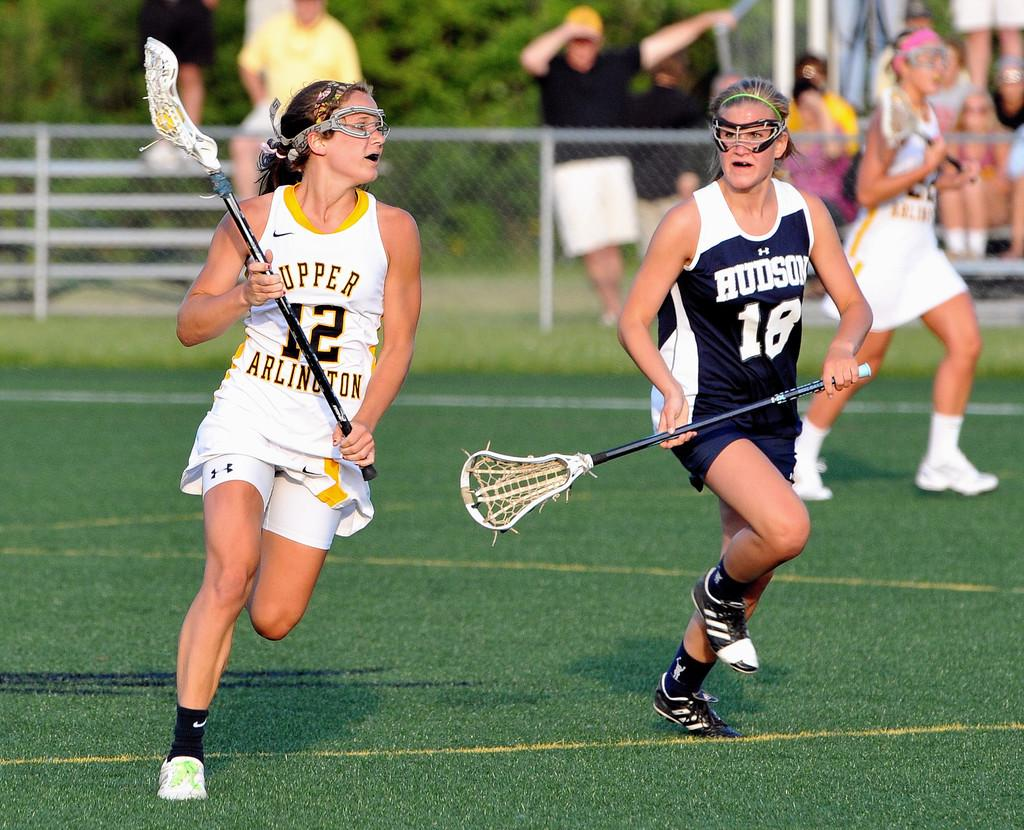How many people are present in the image? There are two women in the image. What are the women doing in the image? The women are running in a playground. What can be seen in the background of the image? There are trees in the background of the image. What type of structure is visible in the image? There is a fencing grill in the image. What type of leather shoes are the women wearing in the image? There is no information about the women's shoes in the image, so we cannot determine if they are wearing leather shoes or any other type of footwear. 